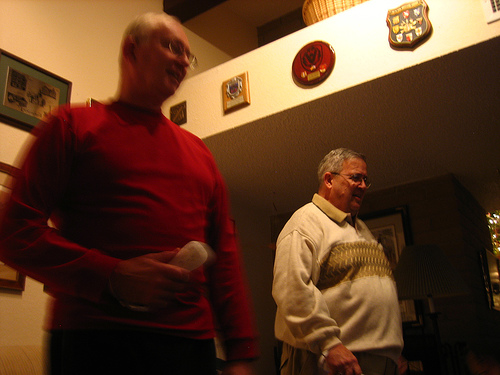What is the person to the right of the remote control wearing? The person to the right of the remote control is wearing a sweater, which is cream in color with a distinctive pattern across the chest. 